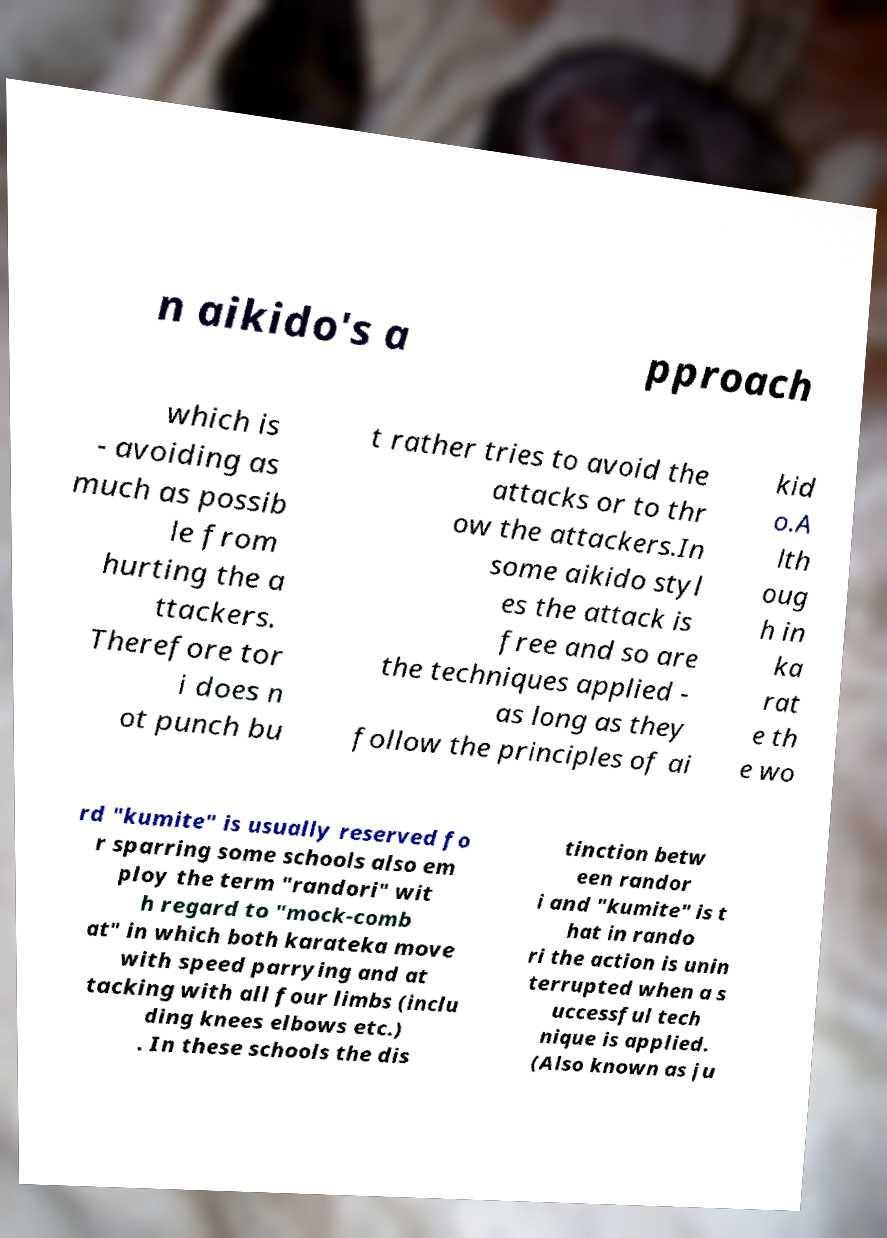Can you read and provide the text displayed in the image?This photo seems to have some interesting text. Can you extract and type it out for me? n aikido's a pproach which is - avoiding as much as possib le from hurting the a ttackers. Therefore tor i does n ot punch bu t rather tries to avoid the attacks or to thr ow the attackers.In some aikido styl es the attack is free and so are the techniques applied - as long as they follow the principles of ai kid o.A lth oug h in ka rat e th e wo rd "kumite" is usually reserved fo r sparring some schools also em ploy the term "randori" wit h regard to "mock-comb at" in which both karateka move with speed parrying and at tacking with all four limbs (inclu ding knees elbows etc.) . In these schools the dis tinction betw een randor i and "kumite" is t hat in rando ri the action is unin terrupted when a s uccessful tech nique is applied. (Also known as ju 